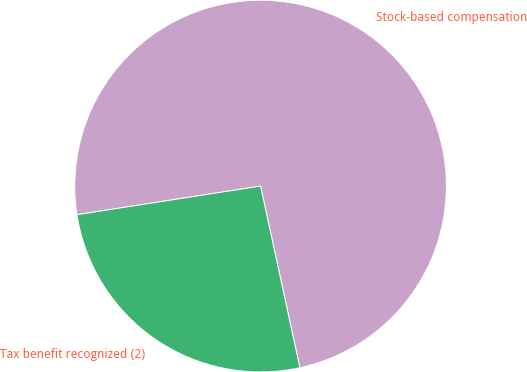<chart> <loc_0><loc_0><loc_500><loc_500><pie_chart><fcel>Stock-based compensation<fcel>Tax benefit recognized (2)<nl><fcel>74.07%<fcel>25.93%<nl></chart> 